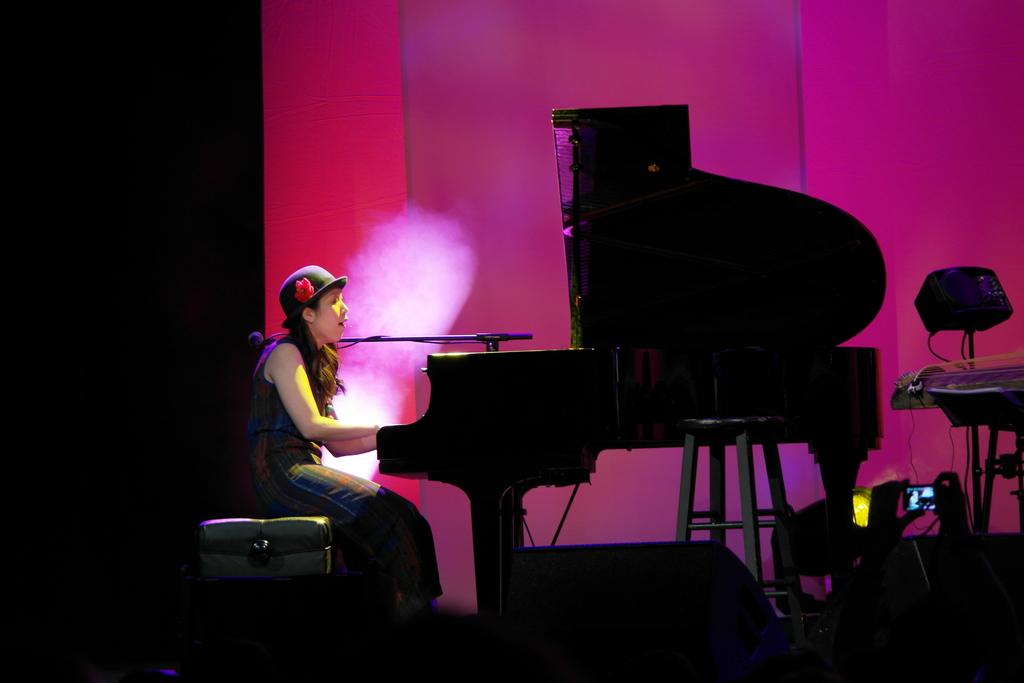Who is the main subject in the image? There is a woman in the image. What is the woman doing in the image? The woman is sitting and playing a piano. What object is in front of the woman? There is a microphone in front of the woman. What type of fang can be seen in the image? There is no fang present in the image. Can you describe the vase on the piano in the image? There is no vase on the piano in the image. 